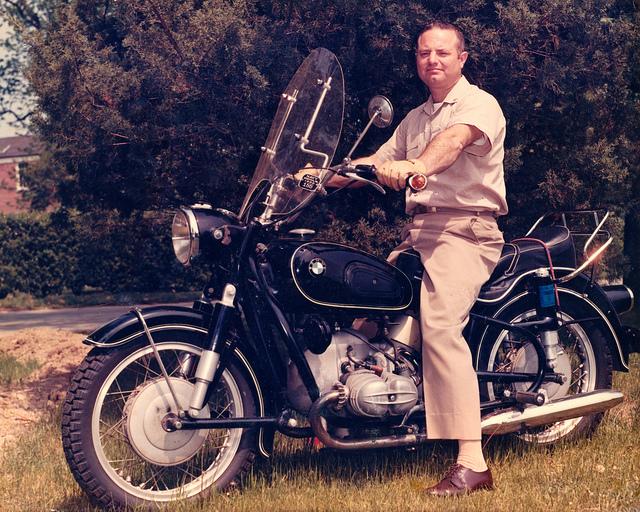What pants is the person wearing?
Keep it brief. Khakis. Why is the windshield so big?
Keep it brief. Block wind. Are this person's pants too short?
Answer briefly. Yes. Why might we assume this is an older photograph?
Write a very short answer. Color. What vehicle is this person on?
Quick response, please. Motorcycle. 